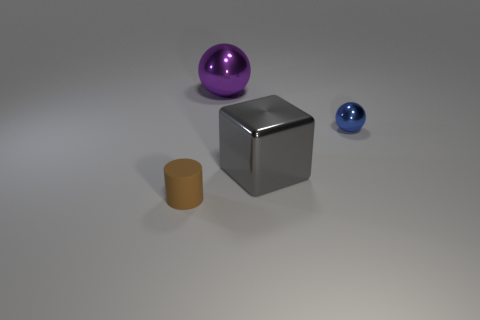How many things are either things behind the blue object or tiny blue balls?
Give a very brief answer. 2. There is a metallic thing left of the metallic cube; what size is it?
Your answer should be very brief. Large. Does the rubber object have the same size as the metallic ball that is on the right side of the large cube?
Offer a very short reply. Yes. There is a tiny object that is behind the tiny object that is in front of the big gray metal cube; what color is it?
Ensure brevity in your answer.  Blue. How many other things are there of the same color as the block?
Give a very brief answer. 0. The cylinder is what size?
Give a very brief answer. Small. Is the number of big metal objects behind the gray cube greater than the number of rubber objects that are behind the small ball?
Provide a succinct answer. Yes. There is a small object to the right of the tiny brown rubber cylinder; how many things are in front of it?
Provide a succinct answer. 2. There is a thing to the left of the purple sphere; is its shape the same as the tiny metal object?
Make the answer very short. No. How many brown rubber cylinders are the same size as the blue thing?
Your answer should be very brief. 1. 